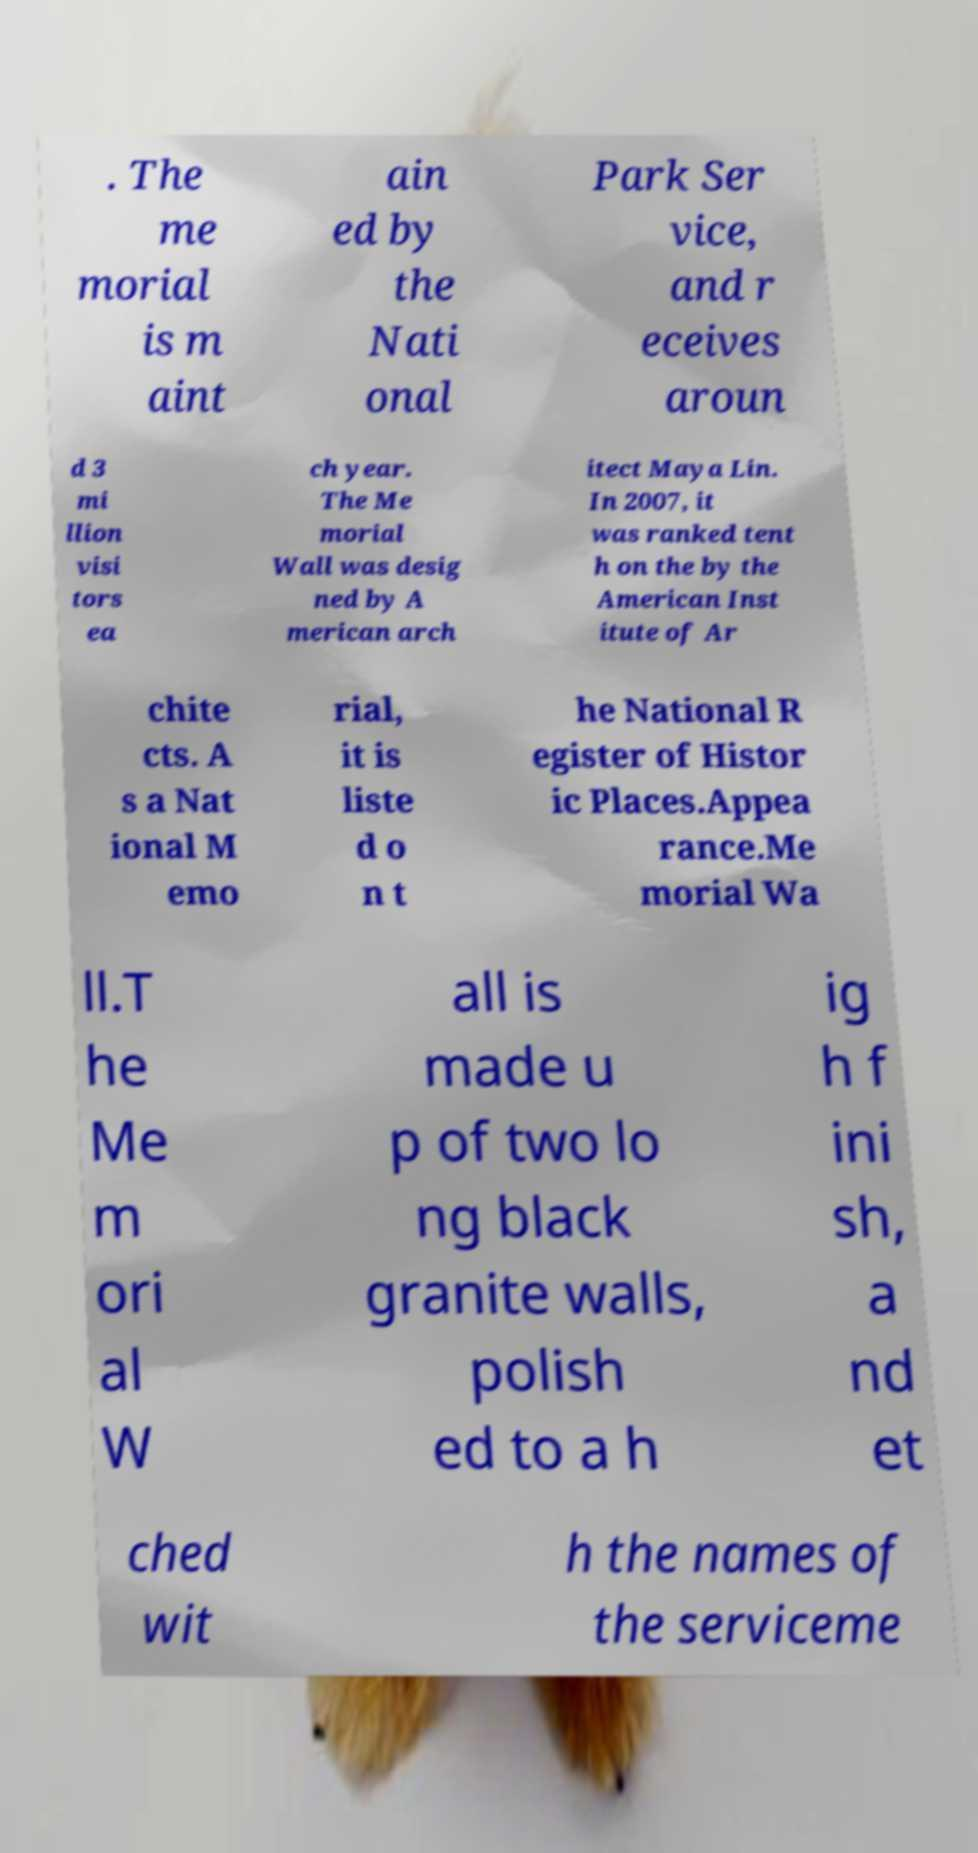Can you read and provide the text displayed in the image?This photo seems to have some interesting text. Can you extract and type it out for me? . The me morial is m aint ain ed by the Nati onal Park Ser vice, and r eceives aroun d 3 mi llion visi tors ea ch year. The Me morial Wall was desig ned by A merican arch itect Maya Lin. In 2007, it was ranked tent h on the by the American Inst itute of Ar chite cts. A s a Nat ional M emo rial, it is liste d o n t he National R egister of Histor ic Places.Appea rance.Me morial Wa ll.T he Me m ori al W all is made u p of two lo ng black granite walls, polish ed to a h ig h f ini sh, a nd et ched wit h the names of the serviceme 